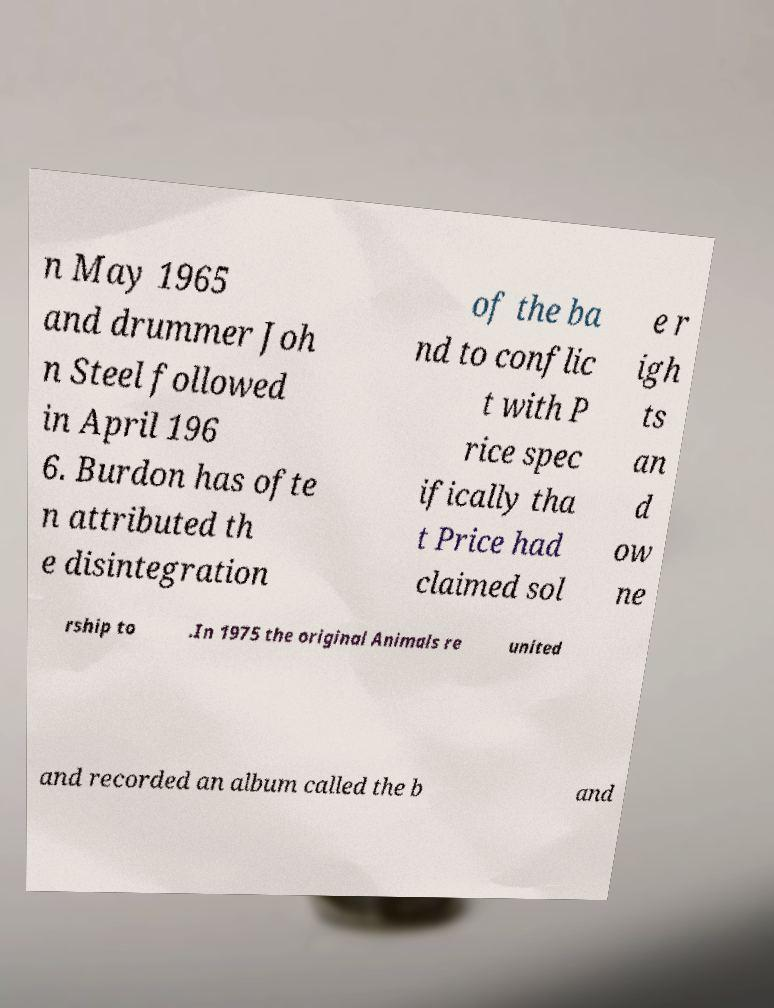What messages or text are displayed in this image? I need them in a readable, typed format. n May 1965 and drummer Joh n Steel followed in April 196 6. Burdon has ofte n attributed th e disintegration of the ba nd to conflic t with P rice spec ifically tha t Price had claimed sol e r igh ts an d ow ne rship to .In 1975 the original Animals re united and recorded an album called the b and 